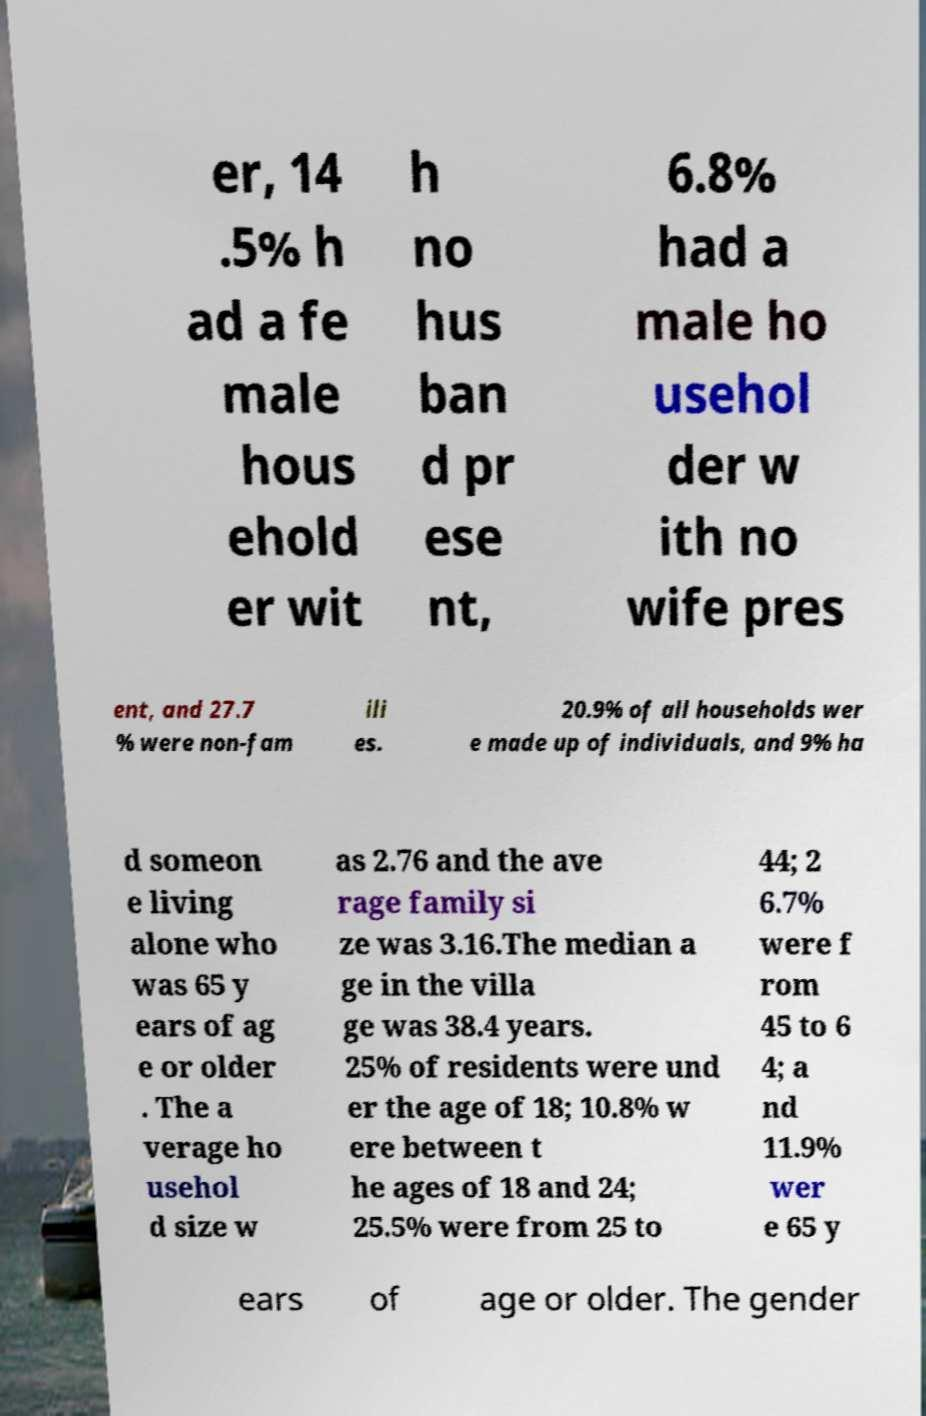I need the written content from this picture converted into text. Can you do that? er, 14 .5% h ad a fe male hous ehold er wit h no hus ban d pr ese nt, 6.8% had a male ho usehol der w ith no wife pres ent, and 27.7 % were non-fam ili es. 20.9% of all households wer e made up of individuals, and 9% ha d someon e living alone who was 65 y ears of ag e or older . The a verage ho usehol d size w as 2.76 and the ave rage family si ze was 3.16.The median a ge in the villa ge was 38.4 years. 25% of residents were und er the age of 18; 10.8% w ere between t he ages of 18 and 24; 25.5% were from 25 to 44; 2 6.7% were f rom 45 to 6 4; a nd 11.9% wer e 65 y ears of age or older. The gender 